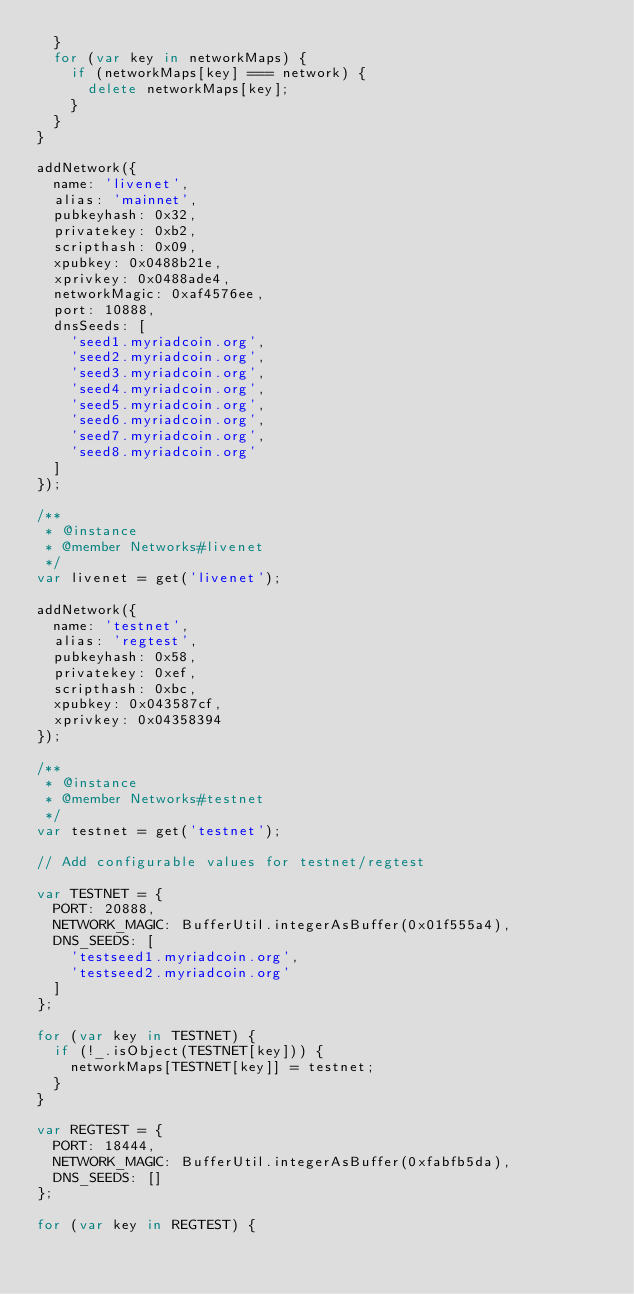Convert code to text. <code><loc_0><loc_0><loc_500><loc_500><_JavaScript_>  }
  for (var key in networkMaps) {
    if (networkMaps[key] === network) {
      delete networkMaps[key];
    }
  }
}

addNetwork({
  name: 'livenet',
  alias: 'mainnet',
  pubkeyhash: 0x32,
  privatekey: 0xb2,
  scripthash: 0x09,
  xpubkey: 0x0488b21e,
  xprivkey: 0x0488ade4,
  networkMagic: 0xaf4576ee,
  port: 10888,
  dnsSeeds: [
    'seed1.myriadcoin.org',
    'seed2.myriadcoin.org',
    'seed3.myriadcoin.org',
    'seed4.myriadcoin.org',
    'seed5.myriadcoin.org',
    'seed6.myriadcoin.org',
    'seed7.myriadcoin.org',
    'seed8.myriadcoin.org'
  ]
});

/**
 * @instance
 * @member Networks#livenet
 */
var livenet = get('livenet');

addNetwork({
  name: 'testnet',
  alias: 'regtest',
  pubkeyhash: 0x58,
  privatekey: 0xef,
  scripthash: 0xbc,
  xpubkey: 0x043587cf,
  xprivkey: 0x04358394
});

/**
 * @instance
 * @member Networks#testnet
 */
var testnet = get('testnet');

// Add configurable values for testnet/regtest

var TESTNET = {
  PORT: 20888,
  NETWORK_MAGIC: BufferUtil.integerAsBuffer(0x01f555a4),
  DNS_SEEDS: [
    'testseed1.myriadcoin.org',
    'testseed2.myriadcoin.org'
  ]
};

for (var key in TESTNET) {
  if (!_.isObject(TESTNET[key])) {
    networkMaps[TESTNET[key]] = testnet;
  }
}

var REGTEST = {
  PORT: 18444,
  NETWORK_MAGIC: BufferUtil.integerAsBuffer(0xfabfb5da),
  DNS_SEEDS: []
};

for (var key in REGTEST) {</code> 